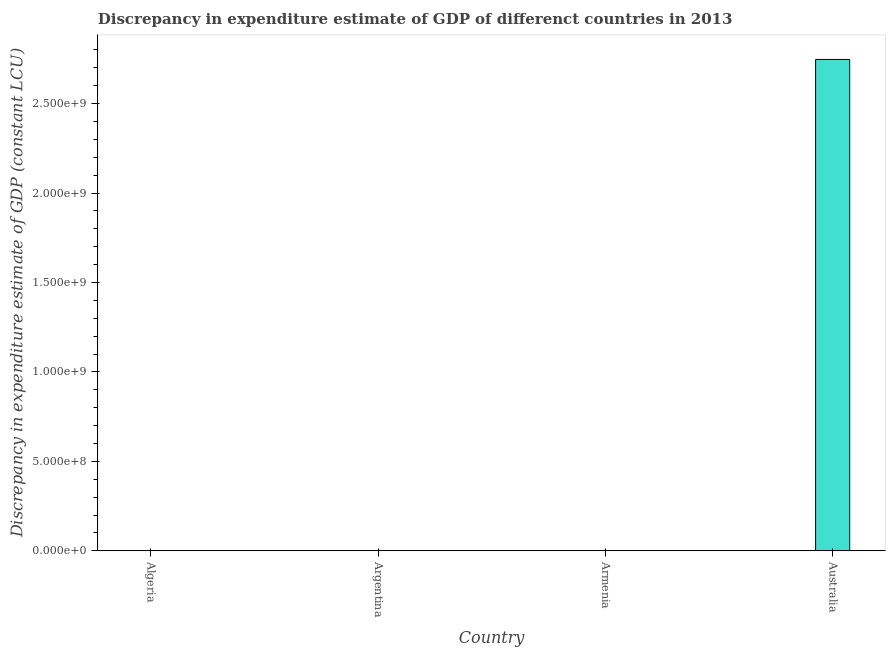Does the graph contain any zero values?
Provide a short and direct response. Yes. Does the graph contain grids?
Provide a short and direct response. No. What is the title of the graph?
Your response must be concise. Discrepancy in expenditure estimate of GDP of differenct countries in 2013. What is the label or title of the Y-axis?
Offer a terse response. Discrepancy in expenditure estimate of GDP (constant LCU). What is the discrepancy in expenditure estimate of gdp in Australia?
Give a very brief answer. 2.75e+09. Across all countries, what is the maximum discrepancy in expenditure estimate of gdp?
Provide a succinct answer. 2.75e+09. Across all countries, what is the minimum discrepancy in expenditure estimate of gdp?
Keep it short and to the point. 0. In which country was the discrepancy in expenditure estimate of gdp maximum?
Your response must be concise. Australia. What is the sum of the discrepancy in expenditure estimate of gdp?
Your response must be concise. 2.75e+09. What is the average discrepancy in expenditure estimate of gdp per country?
Provide a short and direct response. 6.87e+08. What is the median discrepancy in expenditure estimate of gdp?
Your answer should be very brief. 0. What is the difference between the highest and the lowest discrepancy in expenditure estimate of gdp?
Keep it short and to the point. 2.75e+09. In how many countries, is the discrepancy in expenditure estimate of gdp greater than the average discrepancy in expenditure estimate of gdp taken over all countries?
Ensure brevity in your answer.  1. What is the difference between two consecutive major ticks on the Y-axis?
Offer a terse response. 5.00e+08. Are the values on the major ticks of Y-axis written in scientific E-notation?
Keep it short and to the point. Yes. What is the Discrepancy in expenditure estimate of GDP (constant LCU) in Algeria?
Provide a short and direct response. 0. What is the Discrepancy in expenditure estimate of GDP (constant LCU) of Australia?
Your response must be concise. 2.75e+09. 